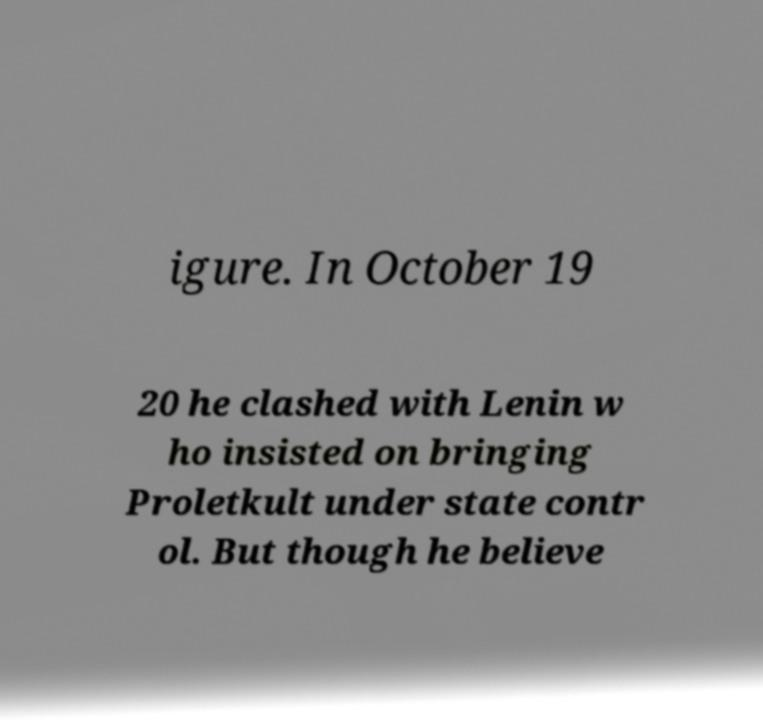There's text embedded in this image that I need extracted. Can you transcribe it verbatim? igure. In October 19 20 he clashed with Lenin w ho insisted on bringing Proletkult under state contr ol. But though he believe 